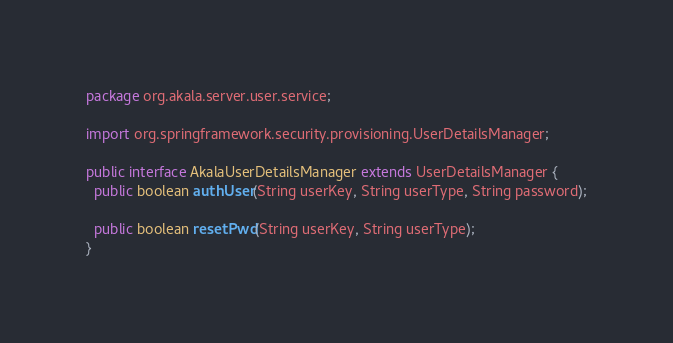<code> <loc_0><loc_0><loc_500><loc_500><_Java_>package org.akala.server.user.service;

import org.springframework.security.provisioning.UserDetailsManager;

public interface AkalaUserDetailsManager extends UserDetailsManager {
  public boolean authUser(String userKey, String userType, String password);

  public boolean resetPwd(String userKey, String userType);
}
</code> 